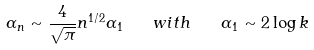Convert formula to latex. <formula><loc_0><loc_0><loc_500><loc_500>\alpha _ { n } \sim \frac { 4 } { \sqrt { \pi } } n ^ { 1 / 2 } \alpha _ { 1 } \quad w i t h \quad \alpha _ { 1 } \sim 2 \log k</formula> 